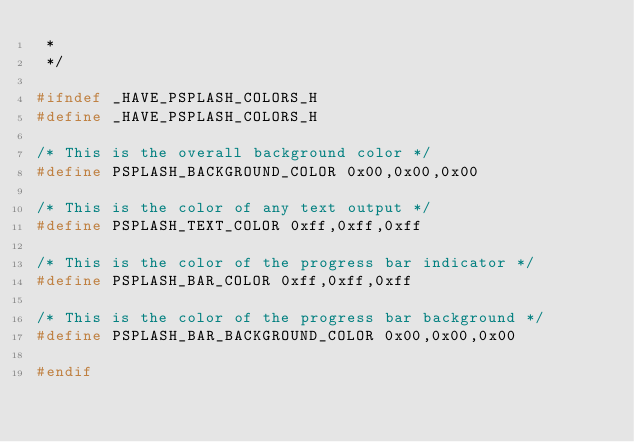Convert code to text. <code><loc_0><loc_0><loc_500><loc_500><_C_> *
 */

#ifndef _HAVE_PSPLASH_COLORS_H
#define _HAVE_PSPLASH_COLORS_H

/* This is the overall background color */
#define PSPLASH_BACKGROUND_COLOR 0x00,0x00,0x00

/* This is the color of any text output */
#define PSPLASH_TEXT_COLOR 0xff,0xff,0xff

/* This is the color of the progress bar indicator */
#define PSPLASH_BAR_COLOR 0xff,0xff,0xff

/* This is the color of the progress bar background */
#define PSPLASH_BAR_BACKGROUND_COLOR 0x00,0x00,0x00

#endif
</code> 